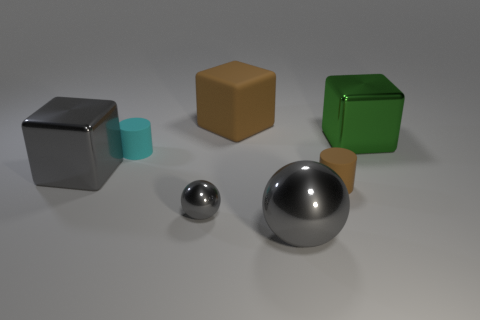The tiny cyan matte thing is what shape?
Provide a succinct answer. Cylinder. What is the color of the metallic object in front of the small sphere right of the small cyan rubber object?
Your answer should be very brief. Gray. There is a gray metal object that is behind the brown cylinder; what size is it?
Give a very brief answer. Large. Are there any large gray spheres that have the same material as the tiny gray object?
Your answer should be very brief. Yes. How many tiny cyan things have the same shape as the tiny brown matte thing?
Your answer should be compact. 1. There is a brown thing that is behind the metal cube that is on the left side of the brown rubber thing that is in front of the large gray metal cube; what shape is it?
Offer a very short reply. Cube. There is a thing that is both in front of the tiny cyan matte thing and behind the brown rubber cylinder; what is it made of?
Your answer should be compact. Metal. Do the metallic block in front of the cyan rubber cylinder and the big brown rubber object have the same size?
Offer a terse response. Yes. Are there any other things that are the same size as the brown matte block?
Your response must be concise. Yes. Is the number of large gray shiny cubes behind the big green object greater than the number of brown rubber cylinders on the right side of the small brown matte cylinder?
Give a very brief answer. No. 